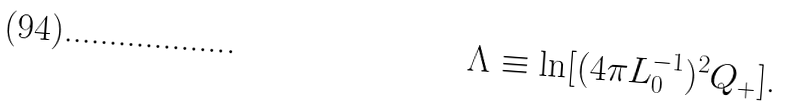<formula> <loc_0><loc_0><loc_500><loc_500>\Lambda \equiv \ln [ ( 4 \pi L _ { 0 } ^ { - 1 } ) ^ { 2 } Q _ { + } ] \text {.}</formula> 